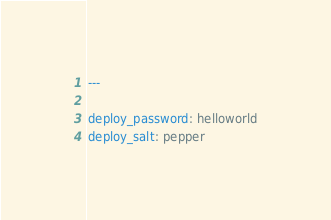<code> <loc_0><loc_0><loc_500><loc_500><_YAML_>---

deploy_password: helloworld
deploy_salt: pepper
</code> 